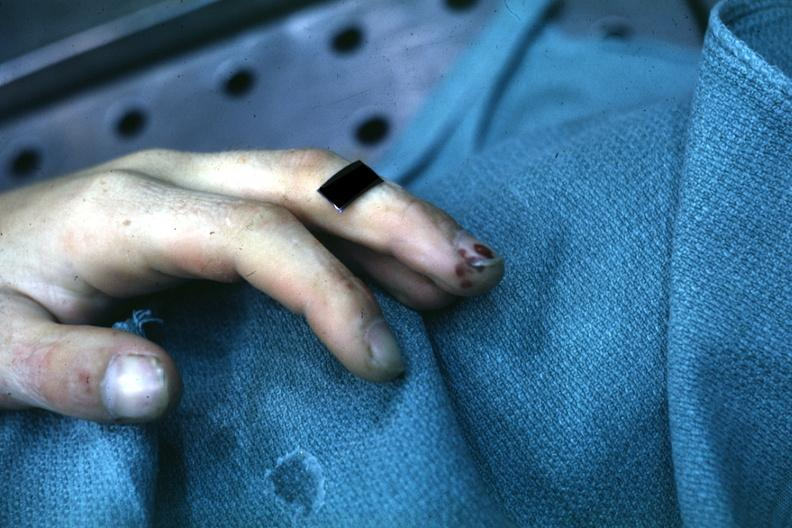s digital infarcts bacterial endocarditis present?
Answer the question using a single word or phrase. Yes 